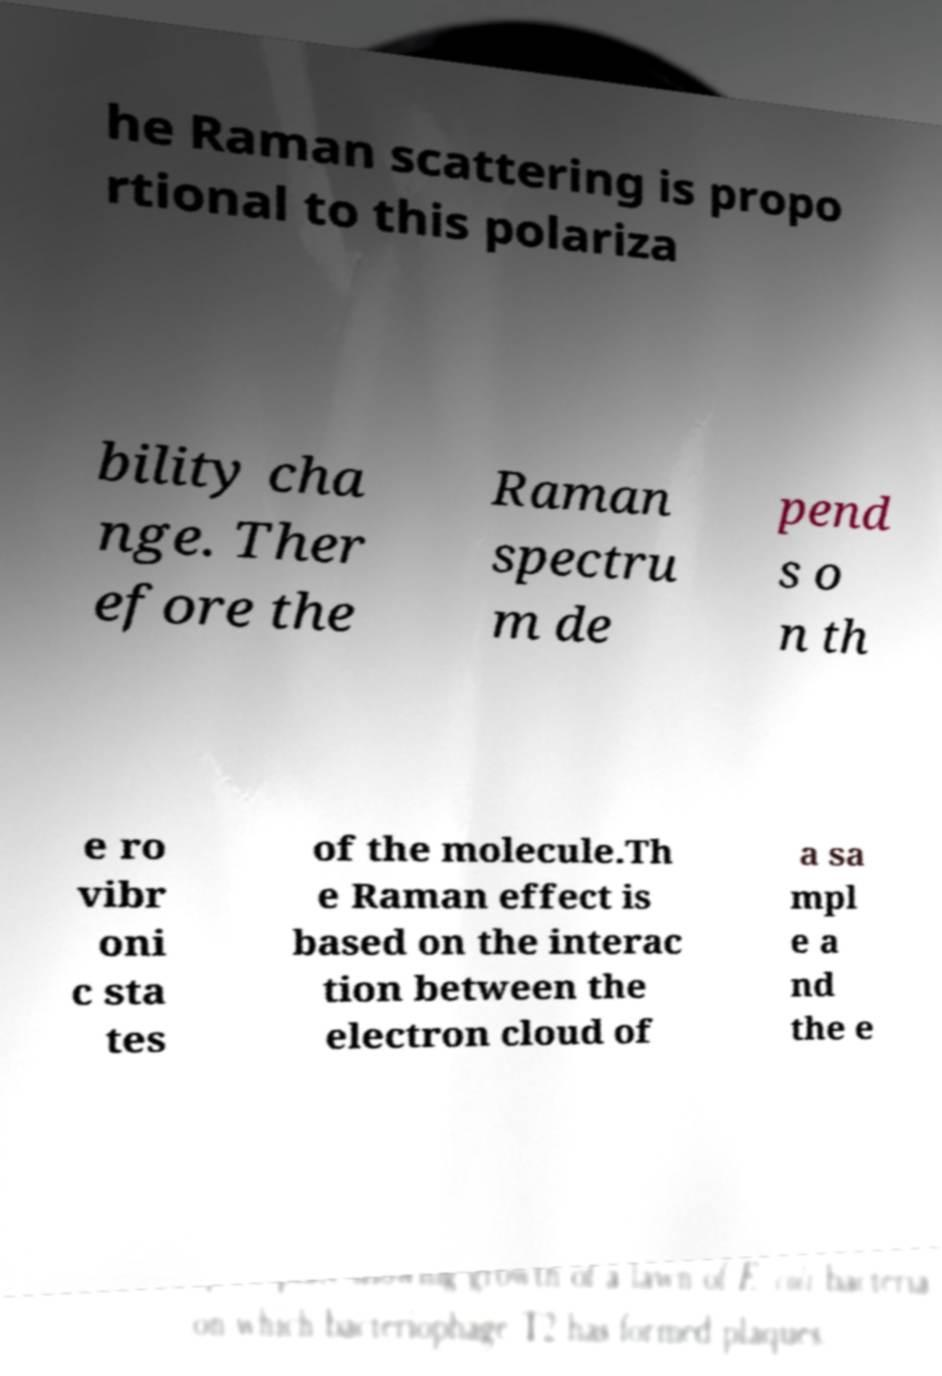Please identify and transcribe the text found in this image. he Raman scattering is propo rtional to this polariza bility cha nge. Ther efore the Raman spectru m de pend s o n th e ro vibr oni c sta tes of the molecule.Th e Raman effect is based on the interac tion between the electron cloud of a sa mpl e a nd the e 